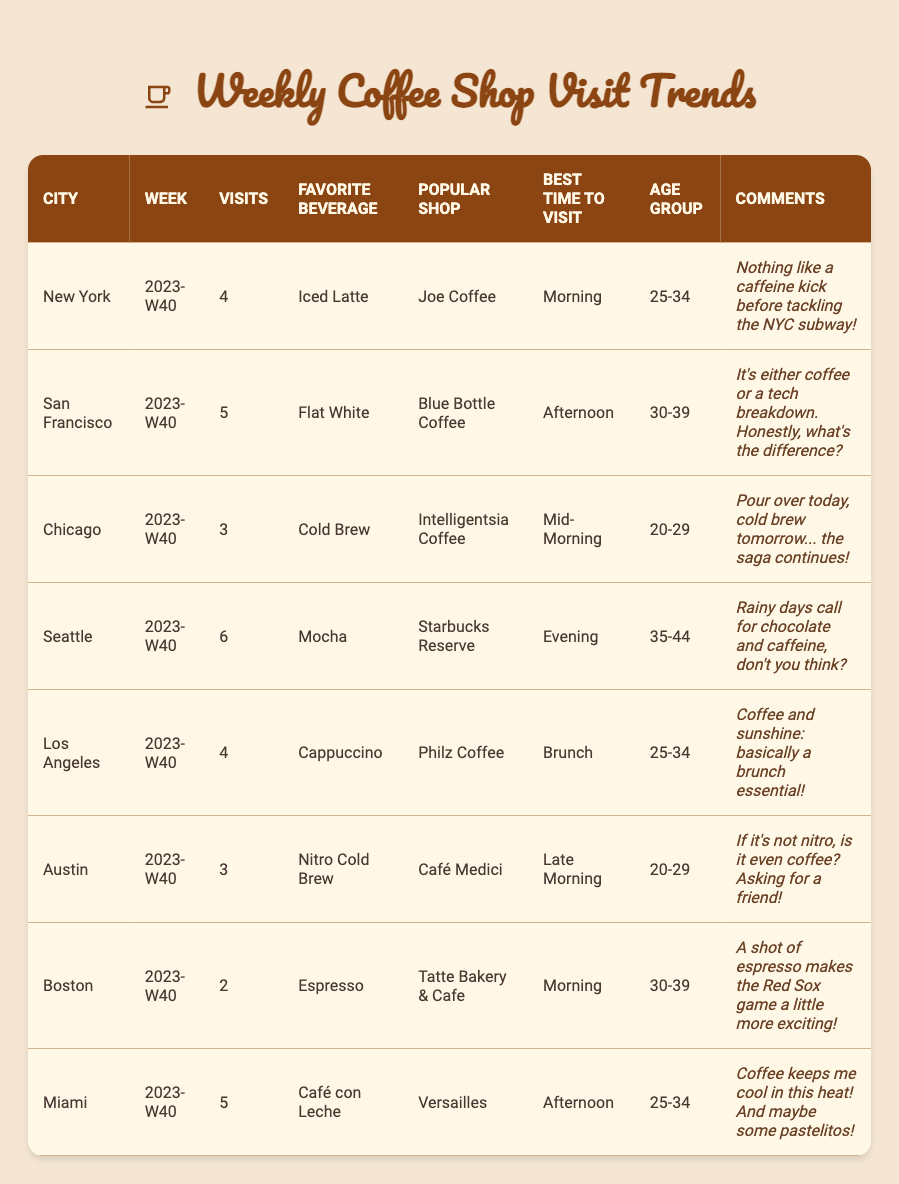How many visits were recorded in Seattle? The table shows that Seattle had 6 visits during week 2023-W40.
Answer: 6 What is the favorite beverage of urban dwellers in San Francisco? According to the table, the favorite beverage in San Francisco is a Flat White.
Answer: Flat White Which city had the least number of coffee shop visits? By comparing the visits across cities, Boston had the least number of visits at 2.
Answer: Boston What age group frequents coffee shops the most in Los Angeles? The table indicates that the age group 25-34 is the one visiting coffee shops the most in Los Angeles.
Answer: 25-34 What is the most popular coffee shop in Chicago? The data reveals that Intelligentsia Coffee is the most popular shop in Chicago.
Answer: Intelligentsia Coffee Which cities have a favorite beverage that includes the word "Cold Brew"? The cities that have a favorite beverage including "Cold Brew" are Chicago and Austin.
Answer: Chicago, Austin What is the average number of coffee shop visits for the listed cities? First, we sum the visits (4+5+3+6+4+3+2+5) = 32, then divide by 8 (the total number of cities) to get an average of 4.
Answer: 4 Is the favorite beverage of Miami urban dwellers a type of coffee? The table lists the favorite beverage for Miami as "Café con Leche," which is a type of coffee. Therefore, the answer is yes.
Answer: Yes Which city has the highest number of overall visits, and what was their favorite beverage? Checking the visits number, Seattle has the highest at 6, and their favorite beverage is Mocha.
Answer: Seattle, Mocha What was the best time to visit coffee shops in Boston? The table indicates that the best time to visit coffee shops in Boston is in the morning.
Answer: Morning 